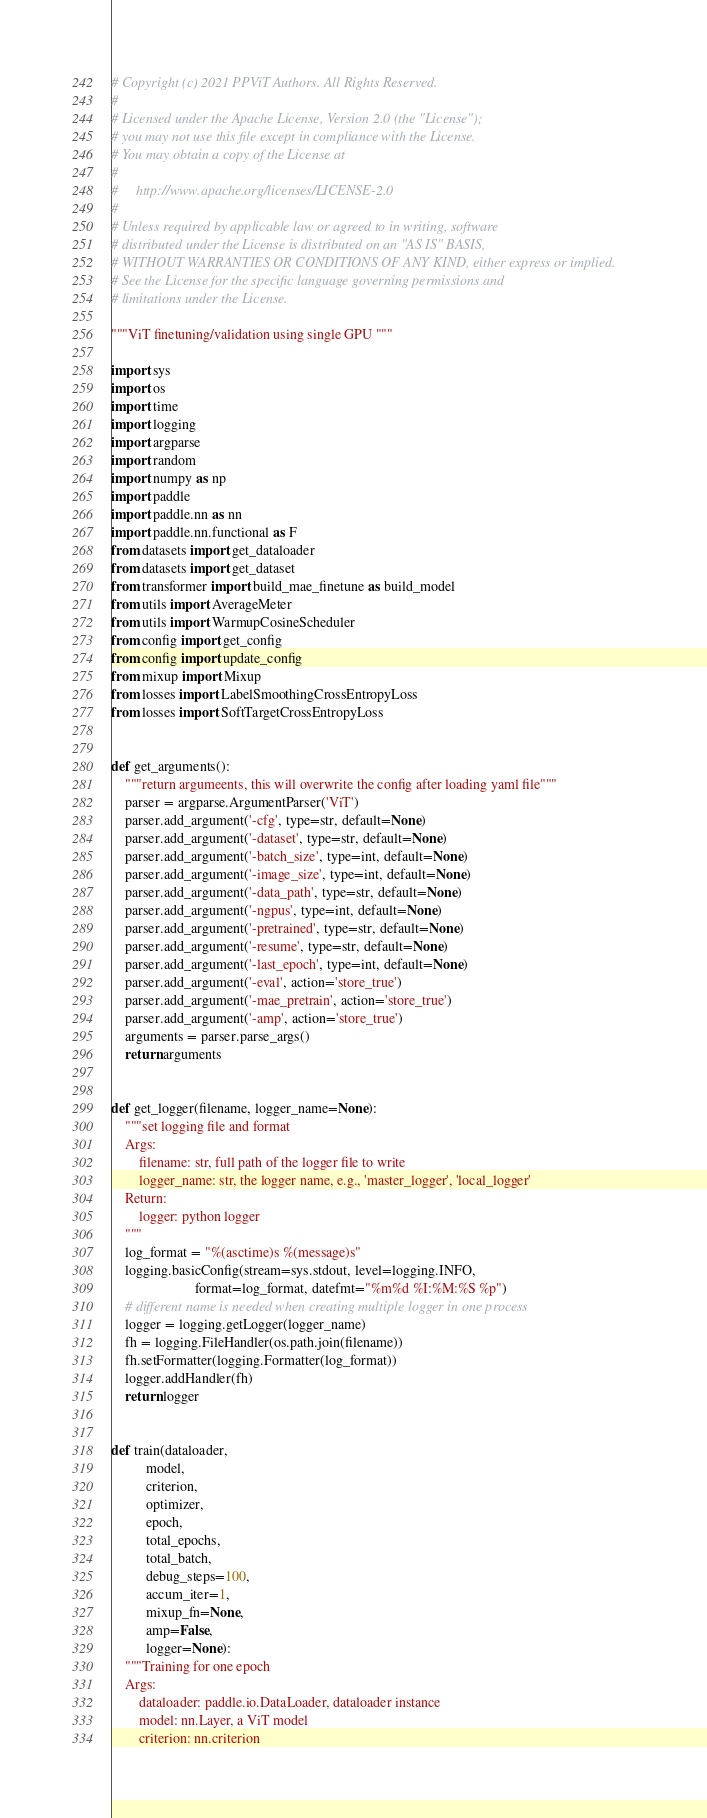Convert code to text. <code><loc_0><loc_0><loc_500><loc_500><_Python_># Copyright (c) 2021 PPViT Authors. All Rights Reserved.
#
# Licensed under the Apache License, Version 2.0 (the "License");
# you may not use this file except in compliance with the License.
# You may obtain a copy of the License at
#
#     http://www.apache.org/licenses/LICENSE-2.0
#
# Unless required by applicable law or agreed to in writing, software
# distributed under the License is distributed on an "AS IS" BASIS,
# WITHOUT WARRANTIES OR CONDITIONS OF ANY KIND, either express or implied.
# See the License for the specific language governing permissions and
# limitations under the License.

"""ViT finetuning/validation using single GPU """

import sys
import os
import time
import logging
import argparse
import random
import numpy as np
import paddle
import paddle.nn as nn
import paddle.nn.functional as F
from datasets import get_dataloader
from datasets import get_dataset
from transformer import build_mae_finetune as build_model
from utils import AverageMeter
from utils import WarmupCosineScheduler
from config import get_config
from config import update_config
from mixup import Mixup
from losses import LabelSmoothingCrossEntropyLoss
from losses import SoftTargetCrossEntropyLoss


def get_arguments():
    """return argumeents, this will overwrite the config after loading yaml file"""
    parser = argparse.ArgumentParser('ViT')
    parser.add_argument('-cfg', type=str, default=None)
    parser.add_argument('-dataset', type=str, default=None)
    parser.add_argument('-batch_size', type=int, default=None)
    parser.add_argument('-image_size', type=int, default=None)
    parser.add_argument('-data_path', type=str, default=None)
    parser.add_argument('-ngpus', type=int, default=None)
    parser.add_argument('-pretrained', type=str, default=None)
    parser.add_argument('-resume', type=str, default=None)
    parser.add_argument('-last_epoch', type=int, default=None)
    parser.add_argument('-eval', action='store_true')
    parser.add_argument('-mae_pretrain', action='store_true')
    parser.add_argument('-amp', action='store_true')
    arguments = parser.parse_args()
    return arguments


def get_logger(filename, logger_name=None):
    """set logging file and format
    Args:
        filename: str, full path of the logger file to write
        logger_name: str, the logger name, e.g., 'master_logger', 'local_logger'
    Return:
        logger: python logger
    """
    log_format = "%(asctime)s %(message)s"
    logging.basicConfig(stream=sys.stdout, level=logging.INFO,
                        format=log_format, datefmt="%m%d %I:%M:%S %p")
    # different name is needed when creating multiple logger in one process
    logger = logging.getLogger(logger_name)
    fh = logging.FileHandler(os.path.join(filename))
    fh.setFormatter(logging.Formatter(log_format))
    logger.addHandler(fh)
    return logger


def train(dataloader,
          model,
          criterion,
          optimizer,
          epoch,
          total_epochs,
          total_batch,
          debug_steps=100,
          accum_iter=1,
          mixup_fn=None,
          amp=False,
          logger=None):
    """Training for one epoch
    Args:
        dataloader: paddle.io.DataLoader, dataloader instance
        model: nn.Layer, a ViT model
        criterion: nn.criterion</code> 